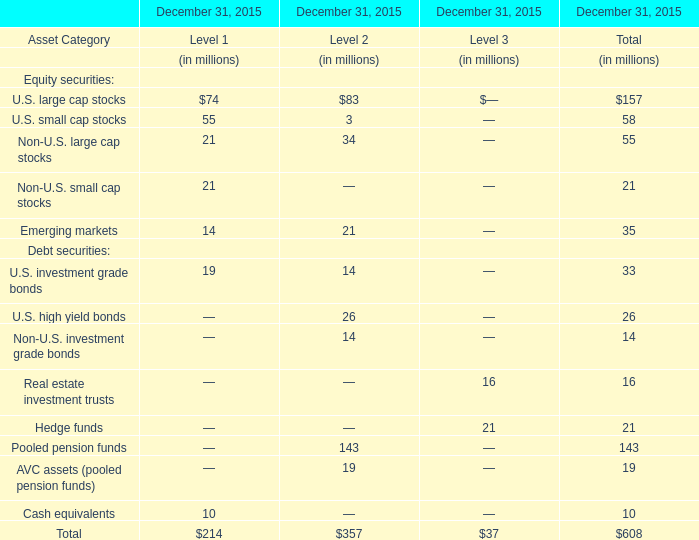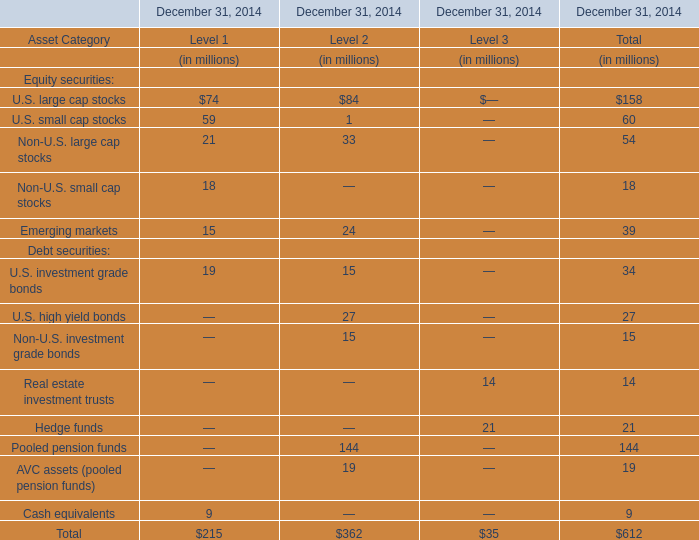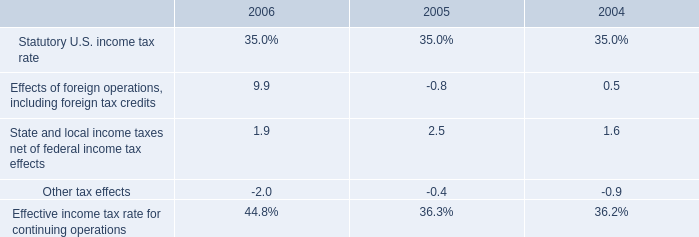In what year is U.S. small cap stocks positive? (in millions) 
Computations: (59 - 0)
Answer: 59.0. 